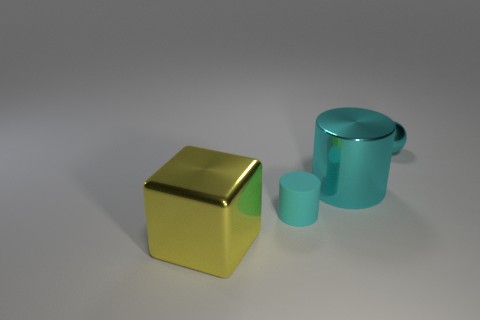What shape is the large object that is the same color as the small matte thing?
Provide a succinct answer. Cylinder. The big cube is what color?
Your answer should be compact. Yellow. What color is the metallic thing that is the same size as the metallic cylinder?
Offer a terse response. Yellow. Are there any large rubber cubes of the same color as the tiny cylinder?
Ensure brevity in your answer.  No. What is the size of the metal cylinder that is the same color as the rubber cylinder?
Ensure brevity in your answer.  Large. Is the color of the metal ball the same as the large object right of the large yellow block?
Give a very brief answer. Yes. Is the number of tiny cyan metallic balls that are to the right of the tiny shiny sphere less than the number of cyan matte cylinders to the left of the tiny rubber cylinder?
Give a very brief answer. No. What color is the thing that is on the right side of the big cube and in front of the cyan metal cylinder?
Offer a terse response. Cyan. How many objects are either cyan objects in front of the metallic cylinder or big blue metal balls?
Give a very brief answer. 1. Are there the same number of small metallic spheres left of the tiny cyan sphere and small cyan balls in front of the metallic cube?
Ensure brevity in your answer.  Yes. 